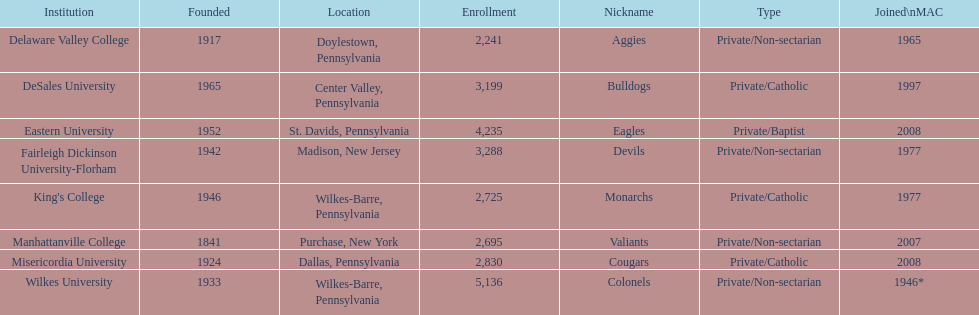How many are enrolled in private/catholic? 8,754. 